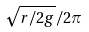<formula> <loc_0><loc_0><loc_500><loc_500>\sqrt { r / 2 g } / 2 \pi</formula> 